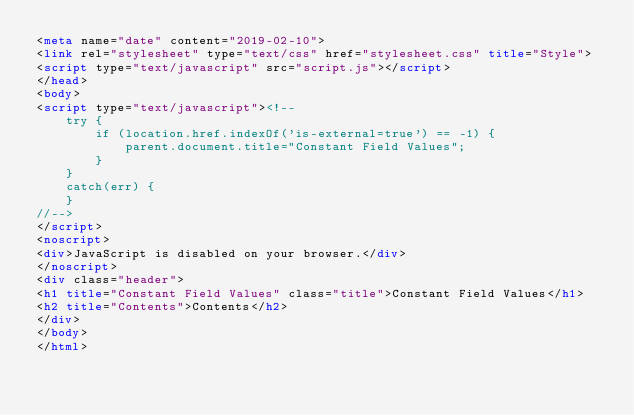<code> <loc_0><loc_0><loc_500><loc_500><_HTML_><meta name="date" content="2019-02-10">
<link rel="stylesheet" type="text/css" href="stylesheet.css" title="Style">
<script type="text/javascript" src="script.js"></script>
</head>
<body>
<script type="text/javascript"><!--
    try {
        if (location.href.indexOf('is-external=true') == -1) {
            parent.document.title="Constant Field Values";
        }
    }
    catch(err) {
    }
//-->
</script>
<noscript>
<div>JavaScript is disabled on your browser.</div>
</noscript>
<div class="header">
<h1 title="Constant Field Values" class="title">Constant Field Values</h1>
<h2 title="Contents">Contents</h2>
</div>
</body>
</html>
</code> 